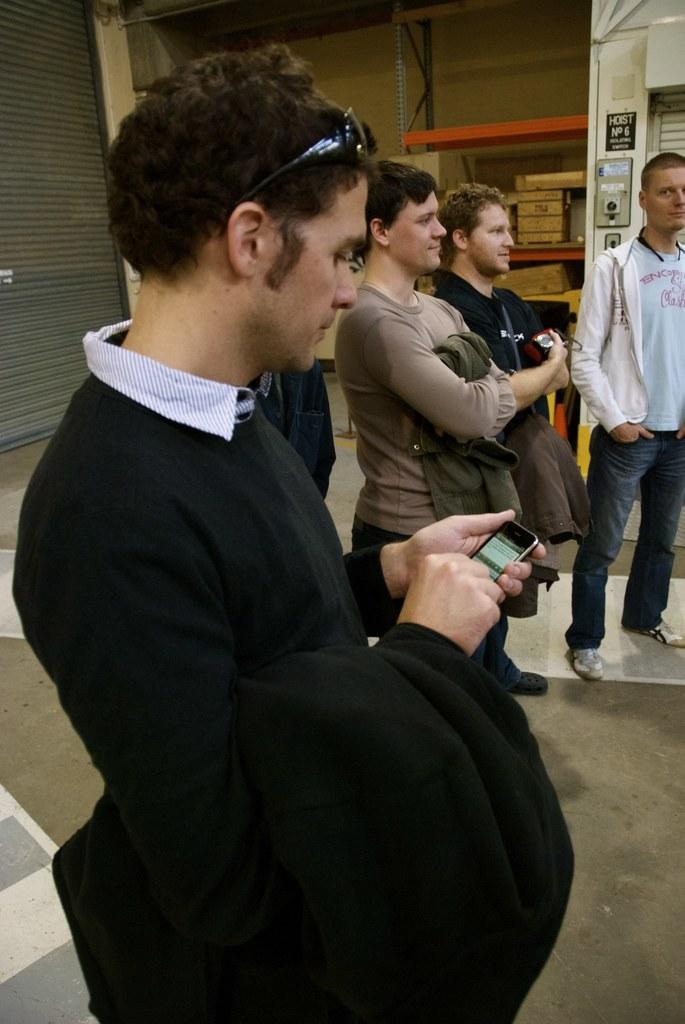What is the main subject of the image? There is a person standing in the center of the image. What is the person holding in the image? The person is holding a mobile phone. Can you describe the background of the image? There are other persons visible in the background, along with a wall and a switch board. What else can be seen in the background? Objects are placed on racks in the background. What is the opinion of the person's brothers about the acoustics in the room? There is no mention of the person having brothers or any discussion about acoustics in the image. 